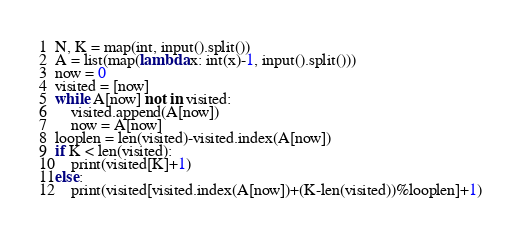<code> <loc_0><loc_0><loc_500><loc_500><_Python_>N, K = map(int, input().split())
A = list(map(lambda x: int(x)-1, input().split()))
now = 0
visited = [now]
while A[now] not in visited:
    visited.append(A[now])
    now = A[now]
looplen = len(visited)-visited.index(A[now])
if K < len(visited):
    print(visited[K]+1)
else:
    print(visited[visited.index(A[now])+(K-len(visited))%looplen]+1)</code> 